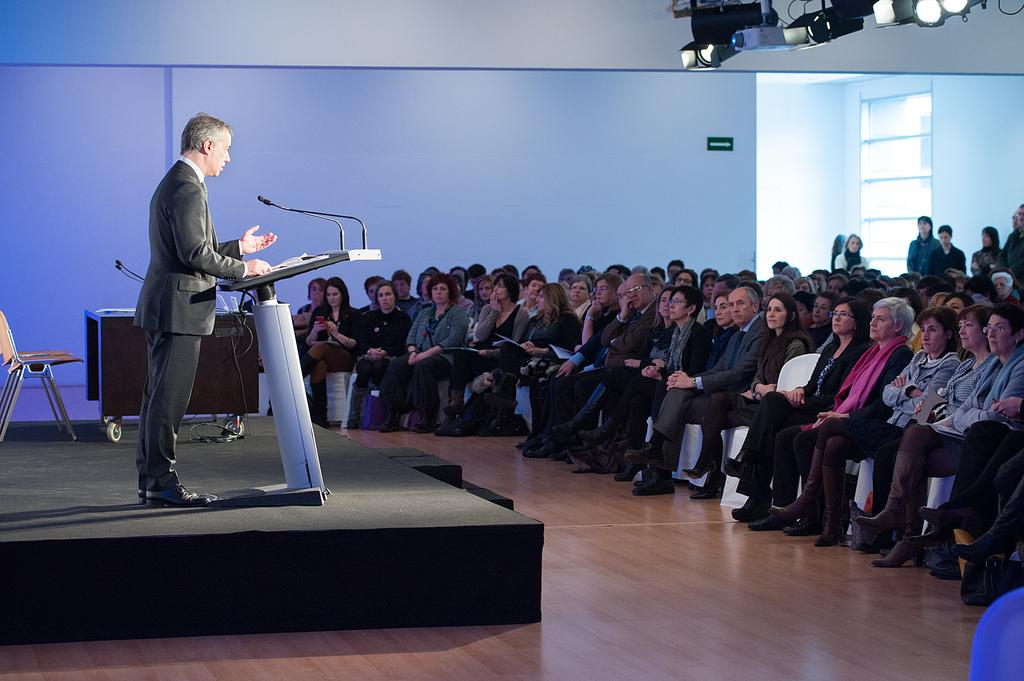What is the person near in the image doing? The person is standing near a podium. What is the person likely to use for speaking in the image? There is a microphone in the image, which the person might use for speaking. What is another piece of furniture present in the image? There is a chair in the image. What type of object can be seen in the image, made of wood? There is a wooden object in the image. What devices are used for displaying visuals in the image? There are projectors in the image. How are the people in the image positioned? There is no head, branch, or building present in the image. What type of tree branch can be seen in the image? There is no tree branch present in the image. What type of building is visible in the image? There is no building present in the image. 